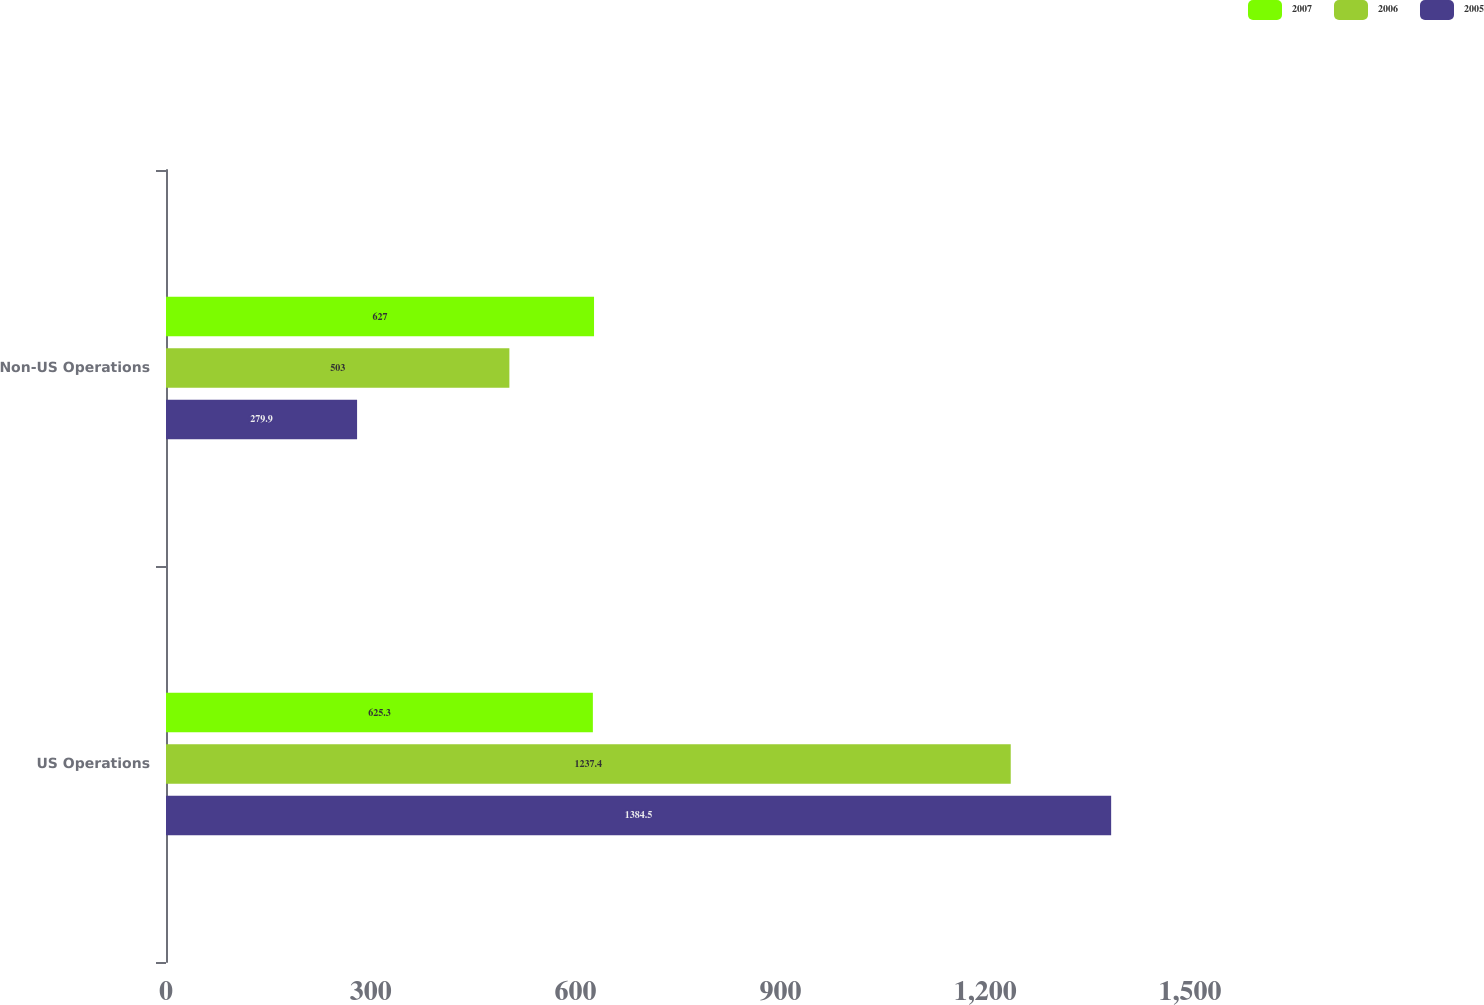Convert chart to OTSL. <chart><loc_0><loc_0><loc_500><loc_500><stacked_bar_chart><ecel><fcel>US Operations<fcel>Non-US Operations<nl><fcel>2007<fcel>625.3<fcel>627<nl><fcel>2006<fcel>1237.4<fcel>503<nl><fcel>2005<fcel>1384.5<fcel>279.9<nl></chart> 